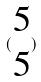<formula> <loc_0><loc_0><loc_500><loc_500>( \begin{matrix} 5 \\ 5 \end{matrix} )</formula> 